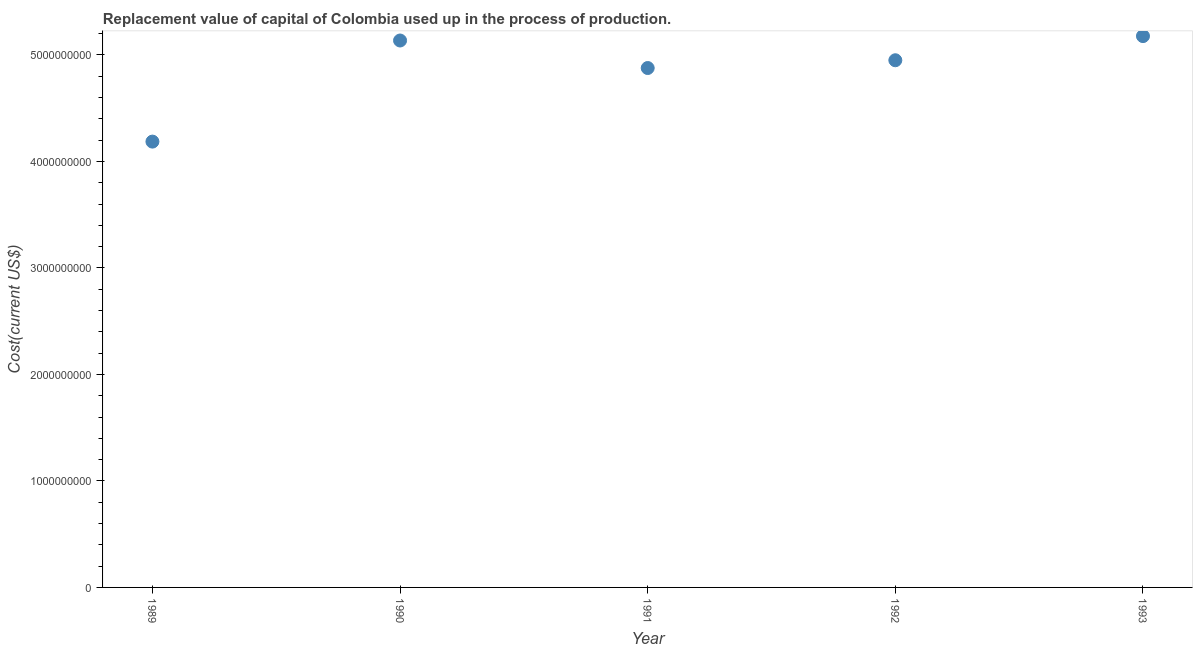What is the consumption of fixed capital in 1990?
Your response must be concise. 5.14e+09. Across all years, what is the maximum consumption of fixed capital?
Keep it short and to the point. 5.18e+09. Across all years, what is the minimum consumption of fixed capital?
Offer a terse response. 4.19e+09. In which year was the consumption of fixed capital minimum?
Make the answer very short. 1989. What is the sum of the consumption of fixed capital?
Offer a very short reply. 2.43e+1. What is the difference between the consumption of fixed capital in 1991 and 1992?
Provide a succinct answer. -7.30e+07. What is the average consumption of fixed capital per year?
Give a very brief answer. 4.87e+09. What is the median consumption of fixed capital?
Provide a succinct answer. 4.95e+09. What is the ratio of the consumption of fixed capital in 1990 to that in 1991?
Your answer should be compact. 1.05. What is the difference between the highest and the second highest consumption of fixed capital?
Make the answer very short. 4.14e+07. Is the sum of the consumption of fixed capital in 1990 and 1992 greater than the maximum consumption of fixed capital across all years?
Give a very brief answer. Yes. What is the difference between the highest and the lowest consumption of fixed capital?
Your answer should be very brief. 9.91e+08. In how many years, is the consumption of fixed capital greater than the average consumption of fixed capital taken over all years?
Your response must be concise. 4. What is the difference between two consecutive major ticks on the Y-axis?
Give a very brief answer. 1.00e+09. Does the graph contain any zero values?
Provide a succinct answer. No. Does the graph contain grids?
Make the answer very short. No. What is the title of the graph?
Your response must be concise. Replacement value of capital of Colombia used up in the process of production. What is the label or title of the Y-axis?
Your response must be concise. Cost(current US$). What is the Cost(current US$) in 1989?
Ensure brevity in your answer.  4.19e+09. What is the Cost(current US$) in 1990?
Ensure brevity in your answer.  5.14e+09. What is the Cost(current US$) in 1991?
Offer a very short reply. 4.88e+09. What is the Cost(current US$) in 1992?
Offer a terse response. 4.95e+09. What is the Cost(current US$) in 1993?
Offer a terse response. 5.18e+09. What is the difference between the Cost(current US$) in 1989 and 1990?
Your response must be concise. -9.49e+08. What is the difference between the Cost(current US$) in 1989 and 1991?
Offer a very short reply. -6.91e+08. What is the difference between the Cost(current US$) in 1989 and 1992?
Make the answer very short. -7.64e+08. What is the difference between the Cost(current US$) in 1989 and 1993?
Ensure brevity in your answer.  -9.91e+08. What is the difference between the Cost(current US$) in 1990 and 1991?
Your response must be concise. 2.58e+08. What is the difference between the Cost(current US$) in 1990 and 1992?
Your response must be concise. 1.85e+08. What is the difference between the Cost(current US$) in 1990 and 1993?
Offer a terse response. -4.14e+07. What is the difference between the Cost(current US$) in 1991 and 1992?
Your answer should be very brief. -7.30e+07. What is the difference between the Cost(current US$) in 1991 and 1993?
Keep it short and to the point. -3.00e+08. What is the difference between the Cost(current US$) in 1992 and 1993?
Provide a short and direct response. -2.27e+08. What is the ratio of the Cost(current US$) in 1989 to that in 1990?
Ensure brevity in your answer.  0.81. What is the ratio of the Cost(current US$) in 1989 to that in 1991?
Offer a terse response. 0.86. What is the ratio of the Cost(current US$) in 1989 to that in 1992?
Provide a succinct answer. 0.85. What is the ratio of the Cost(current US$) in 1989 to that in 1993?
Make the answer very short. 0.81. What is the ratio of the Cost(current US$) in 1990 to that in 1991?
Keep it short and to the point. 1.05. What is the ratio of the Cost(current US$) in 1990 to that in 1992?
Provide a short and direct response. 1.04. What is the ratio of the Cost(current US$) in 1990 to that in 1993?
Offer a very short reply. 0.99. What is the ratio of the Cost(current US$) in 1991 to that in 1992?
Your response must be concise. 0.98. What is the ratio of the Cost(current US$) in 1991 to that in 1993?
Your answer should be very brief. 0.94. What is the ratio of the Cost(current US$) in 1992 to that in 1993?
Offer a terse response. 0.96. 